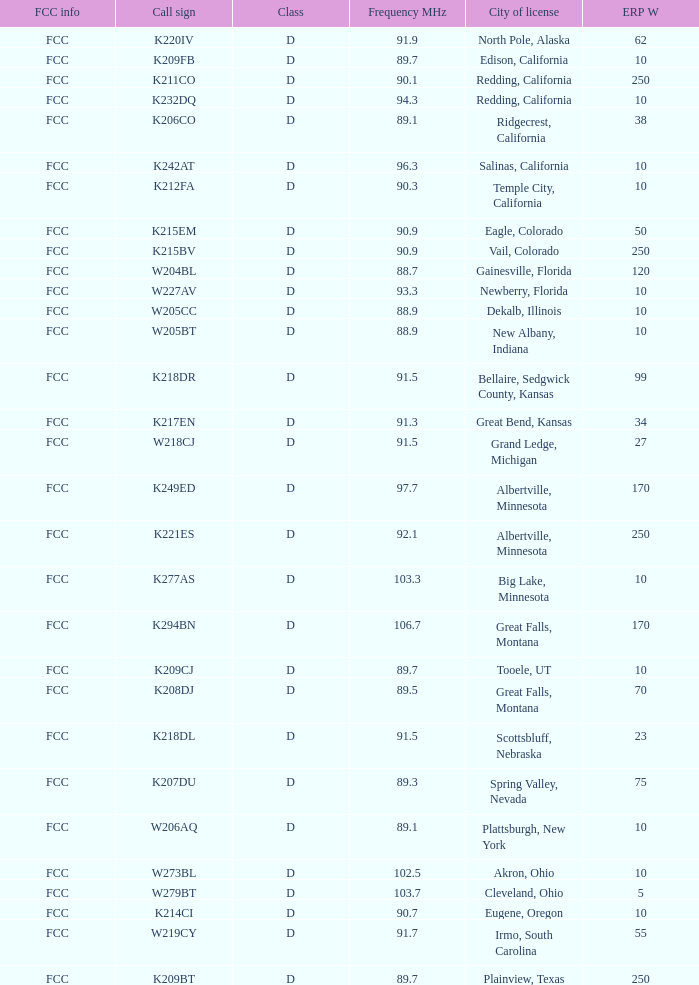What is the highest ERP W of an 89.1 frequency translator? 38.0. 